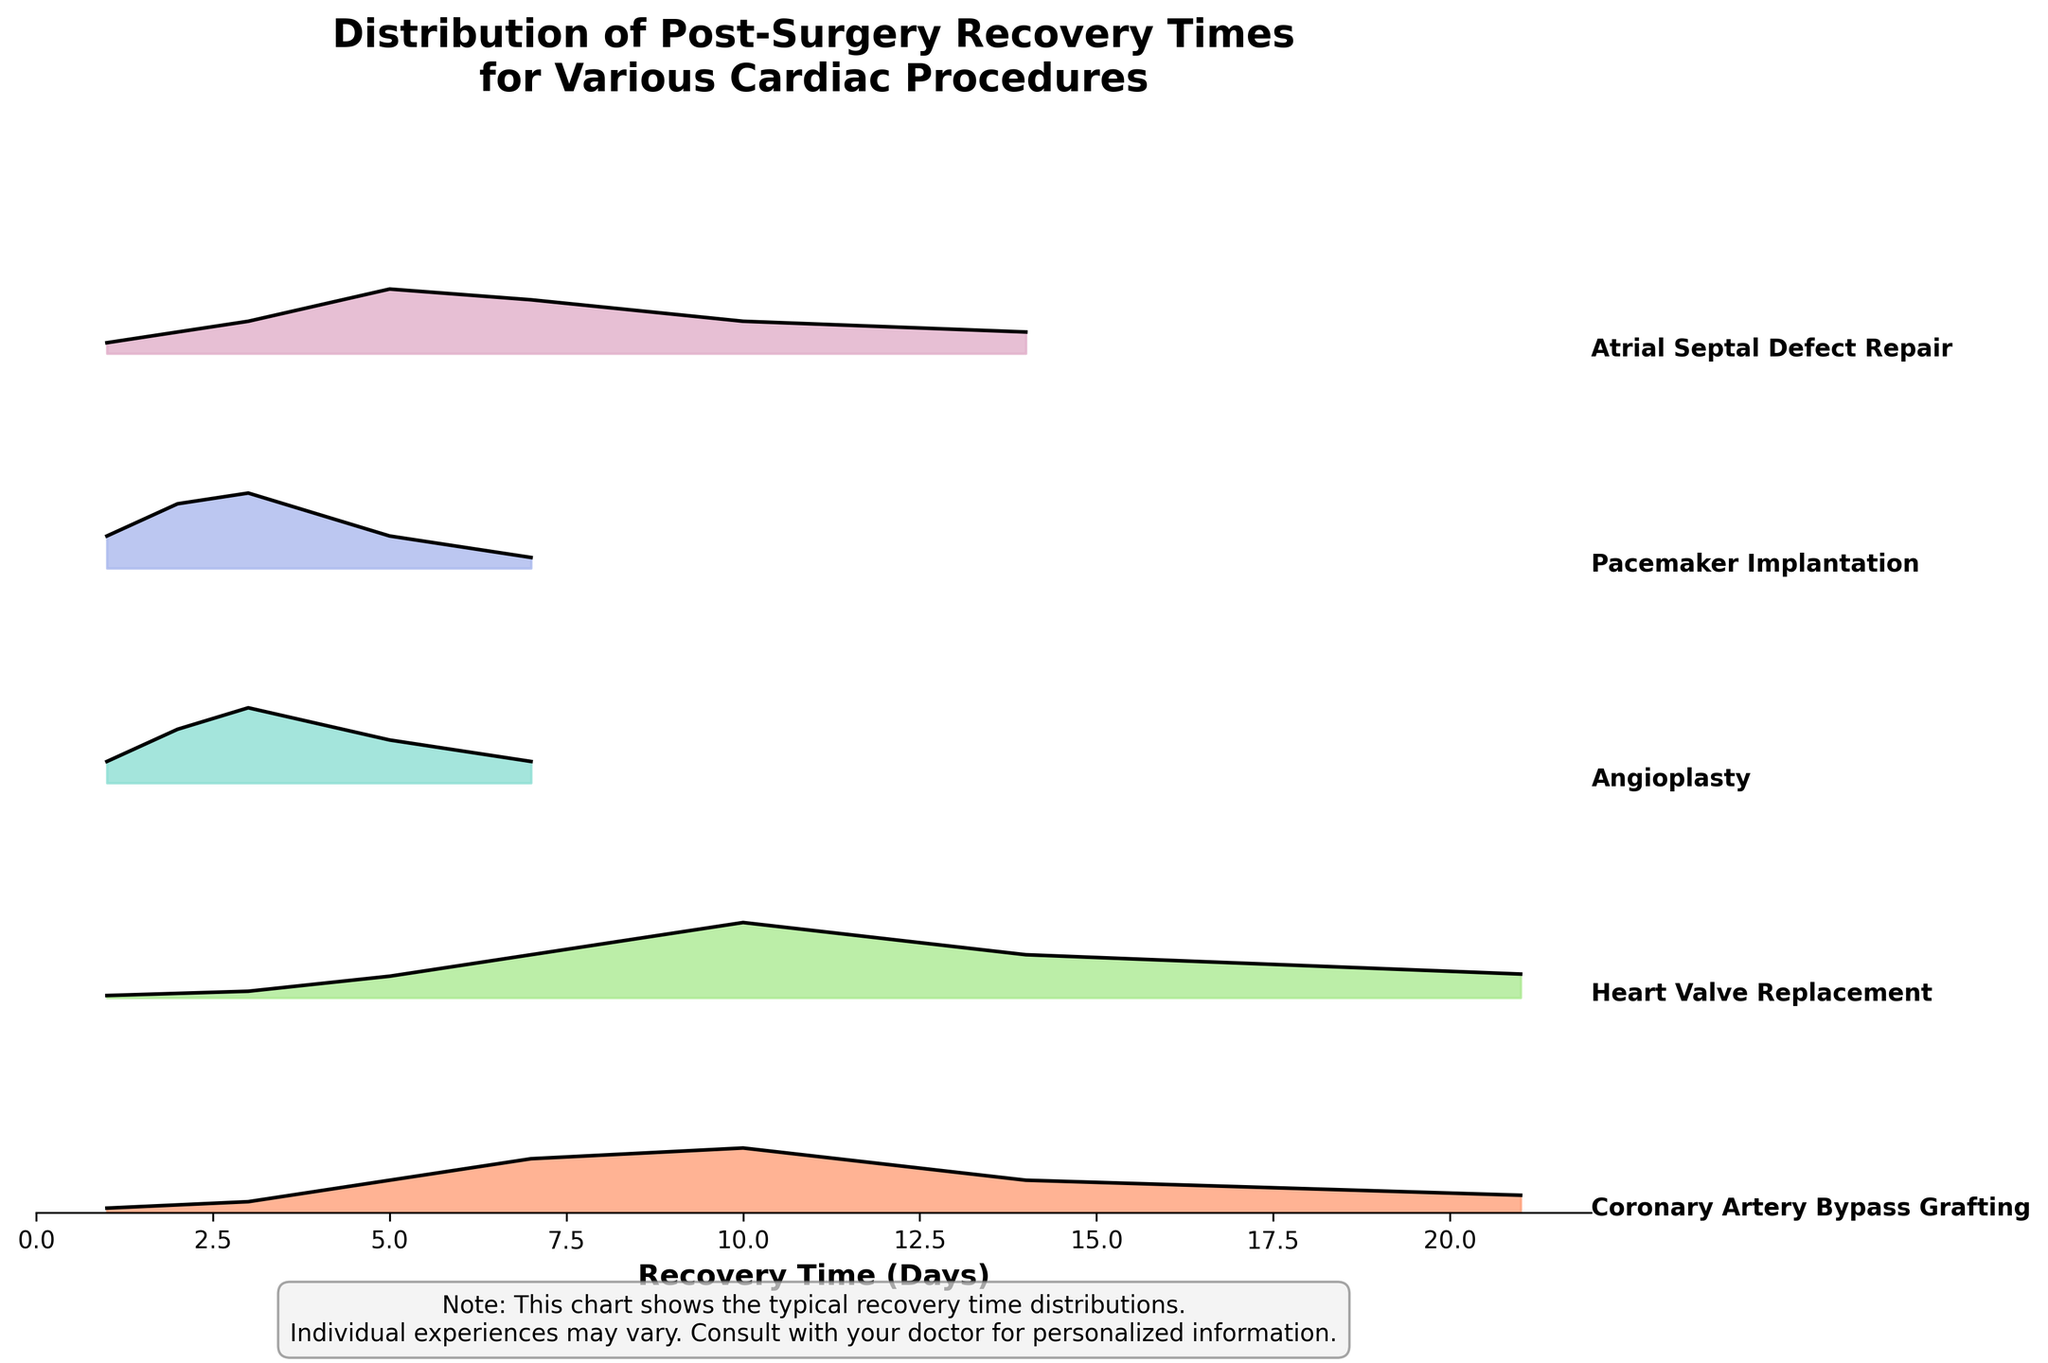What's the title of this figure? The title is located at the top of the figure. It reads: "Distribution of Post-Surgery Recovery Times for Various Cardiac Procedures."
Answer: Distribution of Post-Surgery Recovery Times for Various Cardiac Procedures Which procedure shows the highest density around the 10-day recovery time? By looking at the plot, we can find the procedure with the highest curve at the 10-day point. The procedure labeled "Heart Valve Replacement" has the highest density around 10 days.
Answer: Heart Valve Replacement How many procedures are compared in this figure? The number of unique procedures can be determined by counting the distinct ridgelines. There are five procedures listed in the data.
Answer: Five Which procedure has the shortest most prominent recovery time? We find this by identifying the procedure with the highest peak at the shortest recovery day. "Pacemaker Implantation" has the highest peak around 3 days.
Answer: Pacemaker Implantation What's the general recovery time range presented in this figure? The x-axis has labels showing days from 0 to 22, indicating that recovery times range between 1 and 21 days.
Answer: 1 to 21 days Compare the density of recovery time at 7 days between "Coronary Artery Bypass Grafting" and "Atrial Septal Defect Repair". Which one is higher? Look at the height of the ridgelines at the 7-day mark for both procedures. "Coronary Artery Bypass Grafting" has a density of 0.25 and "Atrial Septal Defect Repair" has a density of 0.25. Therefore, they are equal in density at 7 days.
Answer: Equal Which procedure has the widest distribution of recovery times? The widest distribution can be identified by observing which procedure’s ridgeline covers a larger span along the x-axis. "Heart Valve Replacement" has a wide spread covering several days including 1 through 21 days.
Answer: Heart Valve Replacement What does the x-axis label indicate? The x-axis label is situated at the bottom of the plot and it reads "Recovery Time (Days)". This indicates the number of days taken for post-surgery recovery.
Answer: Recovery Time (Days) What does the note under the figure imply? The note mentions: "This chart shows the typical recovery time distributions. Individual experiences may vary. Consult with your doctor for personalized information." This implies that the distributions shown are averages and may not apply to every individual.
Answer: Individual experiences may vary 